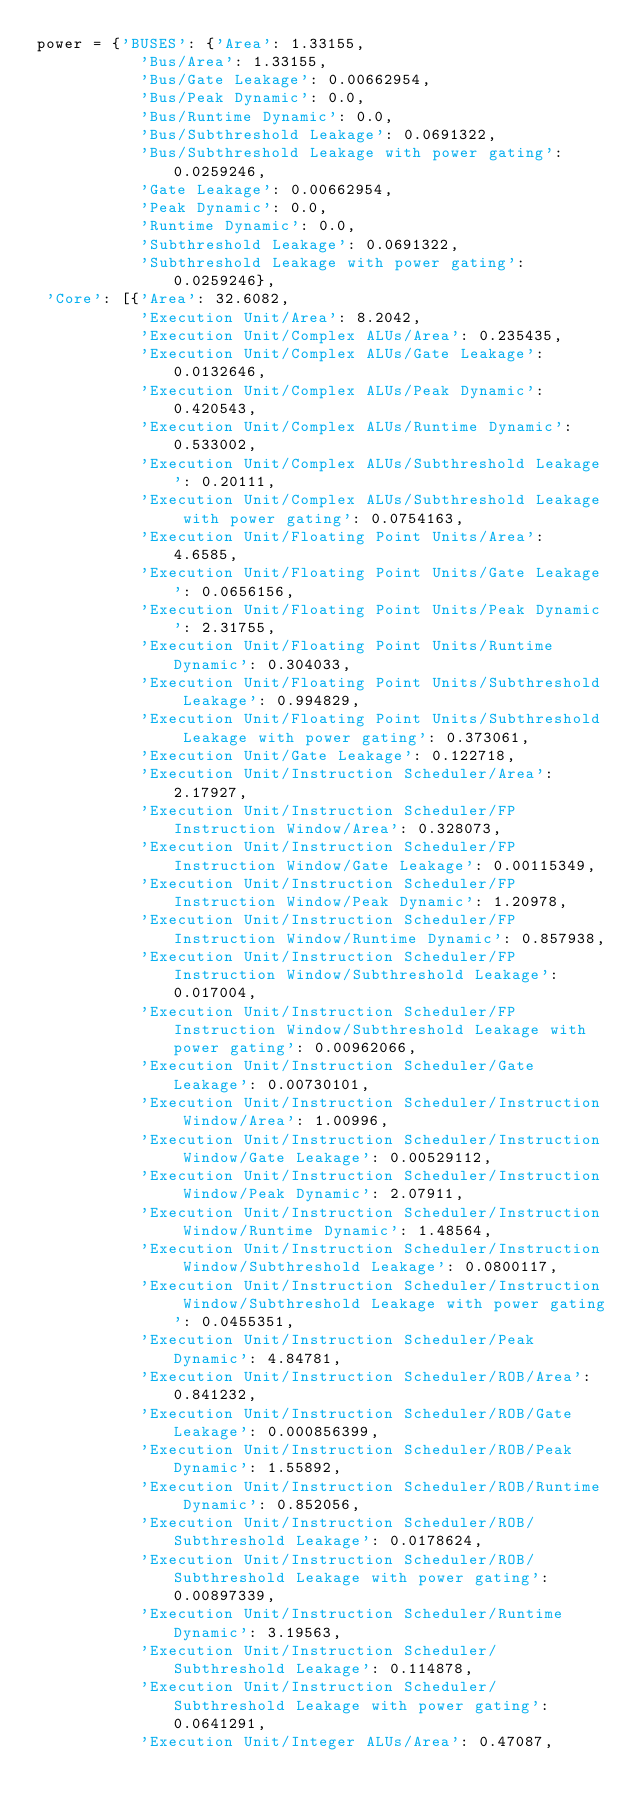<code> <loc_0><loc_0><loc_500><loc_500><_Python_>power = {'BUSES': {'Area': 1.33155,
           'Bus/Area': 1.33155,
           'Bus/Gate Leakage': 0.00662954,
           'Bus/Peak Dynamic': 0.0,
           'Bus/Runtime Dynamic': 0.0,
           'Bus/Subthreshold Leakage': 0.0691322,
           'Bus/Subthreshold Leakage with power gating': 0.0259246,
           'Gate Leakage': 0.00662954,
           'Peak Dynamic': 0.0,
           'Runtime Dynamic': 0.0,
           'Subthreshold Leakage': 0.0691322,
           'Subthreshold Leakage with power gating': 0.0259246},
 'Core': [{'Area': 32.6082,
           'Execution Unit/Area': 8.2042,
           'Execution Unit/Complex ALUs/Area': 0.235435,
           'Execution Unit/Complex ALUs/Gate Leakage': 0.0132646,
           'Execution Unit/Complex ALUs/Peak Dynamic': 0.420543,
           'Execution Unit/Complex ALUs/Runtime Dynamic': 0.533002,
           'Execution Unit/Complex ALUs/Subthreshold Leakage': 0.20111,
           'Execution Unit/Complex ALUs/Subthreshold Leakage with power gating': 0.0754163,
           'Execution Unit/Floating Point Units/Area': 4.6585,
           'Execution Unit/Floating Point Units/Gate Leakage': 0.0656156,
           'Execution Unit/Floating Point Units/Peak Dynamic': 2.31755,
           'Execution Unit/Floating Point Units/Runtime Dynamic': 0.304033,
           'Execution Unit/Floating Point Units/Subthreshold Leakage': 0.994829,
           'Execution Unit/Floating Point Units/Subthreshold Leakage with power gating': 0.373061,
           'Execution Unit/Gate Leakage': 0.122718,
           'Execution Unit/Instruction Scheduler/Area': 2.17927,
           'Execution Unit/Instruction Scheduler/FP Instruction Window/Area': 0.328073,
           'Execution Unit/Instruction Scheduler/FP Instruction Window/Gate Leakage': 0.00115349,
           'Execution Unit/Instruction Scheduler/FP Instruction Window/Peak Dynamic': 1.20978,
           'Execution Unit/Instruction Scheduler/FP Instruction Window/Runtime Dynamic': 0.857938,
           'Execution Unit/Instruction Scheduler/FP Instruction Window/Subthreshold Leakage': 0.017004,
           'Execution Unit/Instruction Scheduler/FP Instruction Window/Subthreshold Leakage with power gating': 0.00962066,
           'Execution Unit/Instruction Scheduler/Gate Leakage': 0.00730101,
           'Execution Unit/Instruction Scheduler/Instruction Window/Area': 1.00996,
           'Execution Unit/Instruction Scheduler/Instruction Window/Gate Leakage': 0.00529112,
           'Execution Unit/Instruction Scheduler/Instruction Window/Peak Dynamic': 2.07911,
           'Execution Unit/Instruction Scheduler/Instruction Window/Runtime Dynamic': 1.48564,
           'Execution Unit/Instruction Scheduler/Instruction Window/Subthreshold Leakage': 0.0800117,
           'Execution Unit/Instruction Scheduler/Instruction Window/Subthreshold Leakage with power gating': 0.0455351,
           'Execution Unit/Instruction Scheduler/Peak Dynamic': 4.84781,
           'Execution Unit/Instruction Scheduler/ROB/Area': 0.841232,
           'Execution Unit/Instruction Scheduler/ROB/Gate Leakage': 0.000856399,
           'Execution Unit/Instruction Scheduler/ROB/Peak Dynamic': 1.55892,
           'Execution Unit/Instruction Scheduler/ROB/Runtime Dynamic': 0.852056,
           'Execution Unit/Instruction Scheduler/ROB/Subthreshold Leakage': 0.0178624,
           'Execution Unit/Instruction Scheduler/ROB/Subthreshold Leakage with power gating': 0.00897339,
           'Execution Unit/Instruction Scheduler/Runtime Dynamic': 3.19563,
           'Execution Unit/Instruction Scheduler/Subthreshold Leakage': 0.114878,
           'Execution Unit/Instruction Scheduler/Subthreshold Leakage with power gating': 0.0641291,
           'Execution Unit/Integer ALUs/Area': 0.47087,</code> 